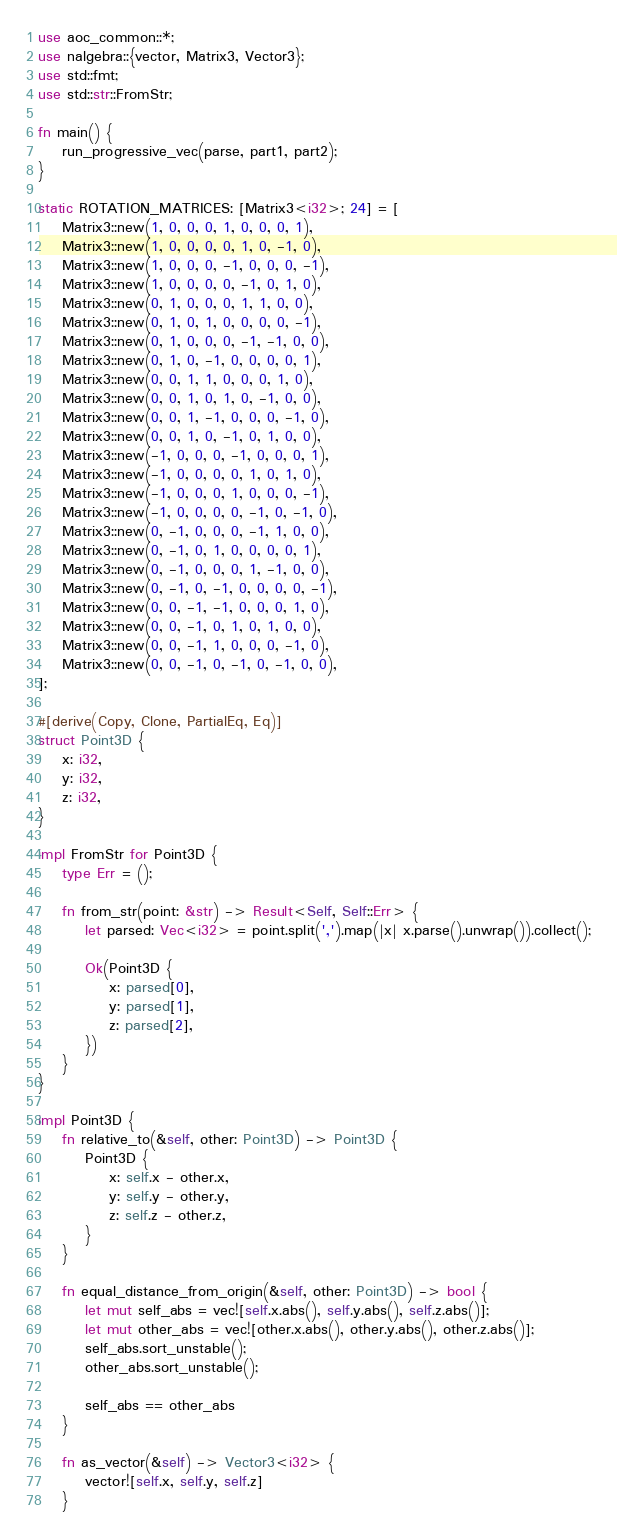Convert code to text. <code><loc_0><loc_0><loc_500><loc_500><_Rust_>use aoc_common::*;
use nalgebra::{vector, Matrix3, Vector3};
use std::fmt;
use std::str::FromStr;

fn main() {
    run_progressive_vec(parse, part1, part2);
}

static ROTATION_MATRICES: [Matrix3<i32>; 24] = [
    Matrix3::new(1, 0, 0, 0, 1, 0, 0, 0, 1),
    Matrix3::new(1, 0, 0, 0, 0, 1, 0, -1, 0),
    Matrix3::new(1, 0, 0, 0, -1, 0, 0, 0, -1),
    Matrix3::new(1, 0, 0, 0, 0, -1, 0, 1, 0),
    Matrix3::new(0, 1, 0, 0, 0, 1, 1, 0, 0),
    Matrix3::new(0, 1, 0, 1, 0, 0, 0, 0, -1),
    Matrix3::new(0, 1, 0, 0, 0, -1, -1, 0, 0),
    Matrix3::new(0, 1, 0, -1, 0, 0, 0, 0, 1),
    Matrix3::new(0, 0, 1, 1, 0, 0, 0, 1, 0),
    Matrix3::new(0, 0, 1, 0, 1, 0, -1, 0, 0),
    Matrix3::new(0, 0, 1, -1, 0, 0, 0, -1, 0),
    Matrix3::new(0, 0, 1, 0, -1, 0, 1, 0, 0),
    Matrix3::new(-1, 0, 0, 0, -1, 0, 0, 0, 1),
    Matrix3::new(-1, 0, 0, 0, 0, 1, 0, 1, 0),
    Matrix3::new(-1, 0, 0, 0, 1, 0, 0, 0, -1),
    Matrix3::new(-1, 0, 0, 0, 0, -1, 0, -1, 0),
    Matrix3::new(0, -1, 0, 0, 0, -1, 1, 0, 0),
    Matrix3::new(0, -1, 0, 1, 0, 0, 0, 0, 1),
    Matrix3::new(0, -1, 0, 0, 0, 1, -1, 0, 0),
    Matrix3::new(0, -1, 0, -1, 0, 0, 0, 0, -1),
    Matrix3::new(0, 0, -1, -1, 0, 0, 0, 1, 0),
    Matrix3::new(0, 0, -1, 0, 1, 0, 1, 0, 0),
    Matrix3::new(0, 0, -1, 1, 0, 0, 0, -1, 0),
    Matrix3::new(0, 0, -1, 0, -1, 0, -1, 0, 0),
];

#[derive(Copy, Clone, PartialEq, Eq)]
struct Point3D {
    x: i32,
    y: i32,
    z: i32,
}

impl FromStr for Point3D {
    type Err = ();

    fn from_str(point: &str) -> Result<Self, Self::Err> {
        let parsed: Vec<i32> = point.split(',').map(|x| x.parse().unwrap()).collect();

        Ok(Point3D {
            x: parsed[0],
            y: parsed[1],
            z: parsed[2],
        })
    }
}

impl Point3D {
    fn relative_to(&self, other: Point3D) -> Point3D {
        Point3D {
            x: self.x - other.x,
            y: self.y - other.y,
            z: self.z - other.z,
        }
    }

    fn equal_distance_from_origin(&self, other: Point3D) -> bool {
        let mut self_abs = vec![self.x.abs(), self.y.abs(), self.z.abs()];
        let mut other_abs = vec![other.x.abs(), other.y.abs(), other.z.abs()];
        self_abs.sort_unstable();
        other_abs.sort_unstable();

        self_abs == other_abs
    }

    fn as_vector(&self) -> Vector3<i32> {
        vector![self.x, self.y, self.z]
    }
</code> 